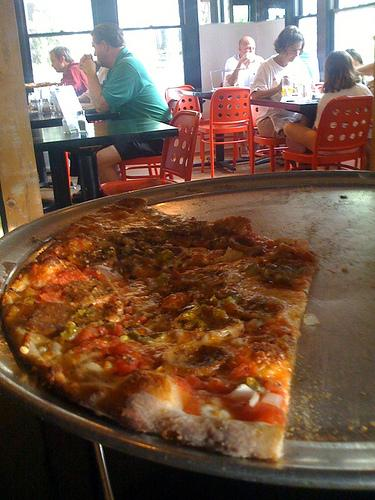What category of pizza would this fall into? california-style 